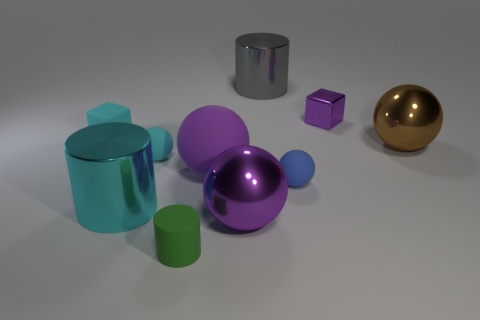Do the small metal cube and the big matte ball have the same color?
Your answer should be compact. Yes. Is the color of the metallic cylinder in front of the small shiny cube the same as the tiny rubber block?
Provide a short and direct response. Yes. Is there any other thing that is the same color as the large matte sphere?
Your answer should be compact. Yes. What is the material of the large cylinder to the left of the green matte object?
Make the answer very short. Metal. Are there more large brown things than large brown matte spheres?
Provide a succinct answer. Yes. Is the shape of the matte object on the right side of the big gray metallic thing the same as  the big gray metal object?
Your answer should be very brief. No. How many large metal things are behind the cyan block and to the right of the gray cylinder?
Ensure brevity in your answer.  0. What number of big purple shiny objects are the same shape as the tiny green thing?
Make the answer very short. 0. What color is the big metallic object that is left of the purple thing that is in front of the blue matte ball?
Ensure brevity in your answer.  Cyan. Does the large rubber thing have the same shape as the small cyan thing that is behind the small cyan matte sphere?
Your answer should be very brief. No. 